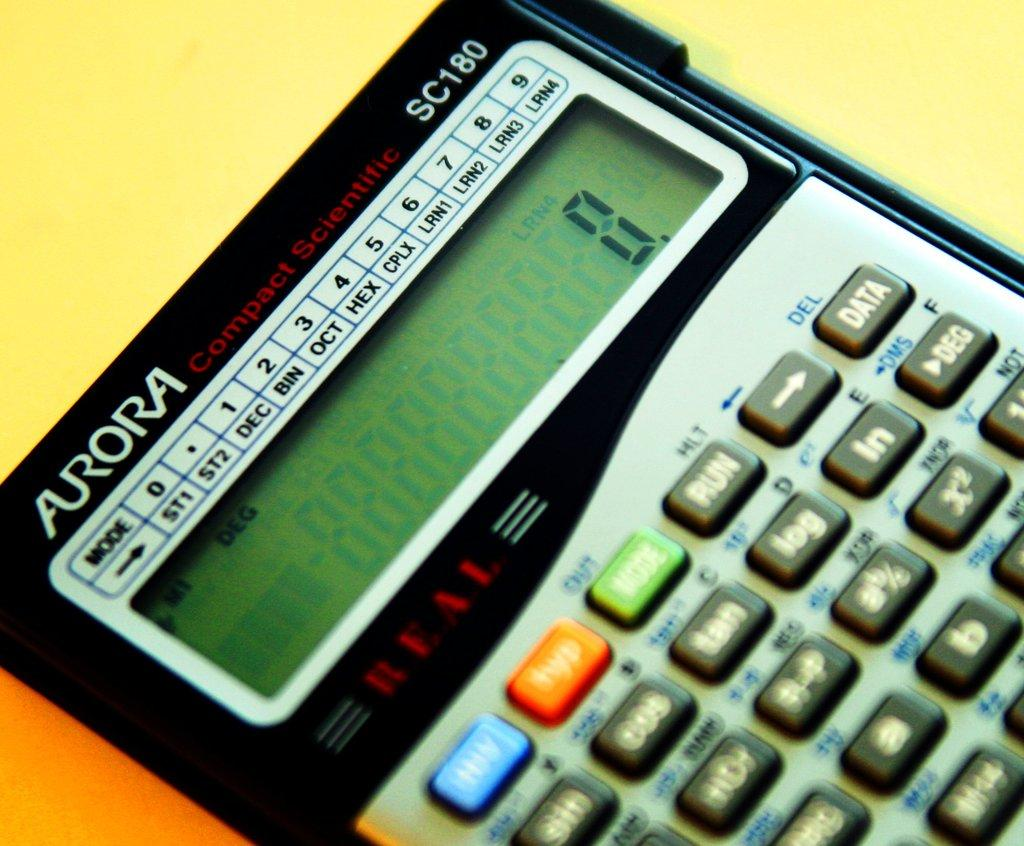<image>
Offer a succinct explanation of the picture presented. A calculator that has the numeric value zero entered into it 